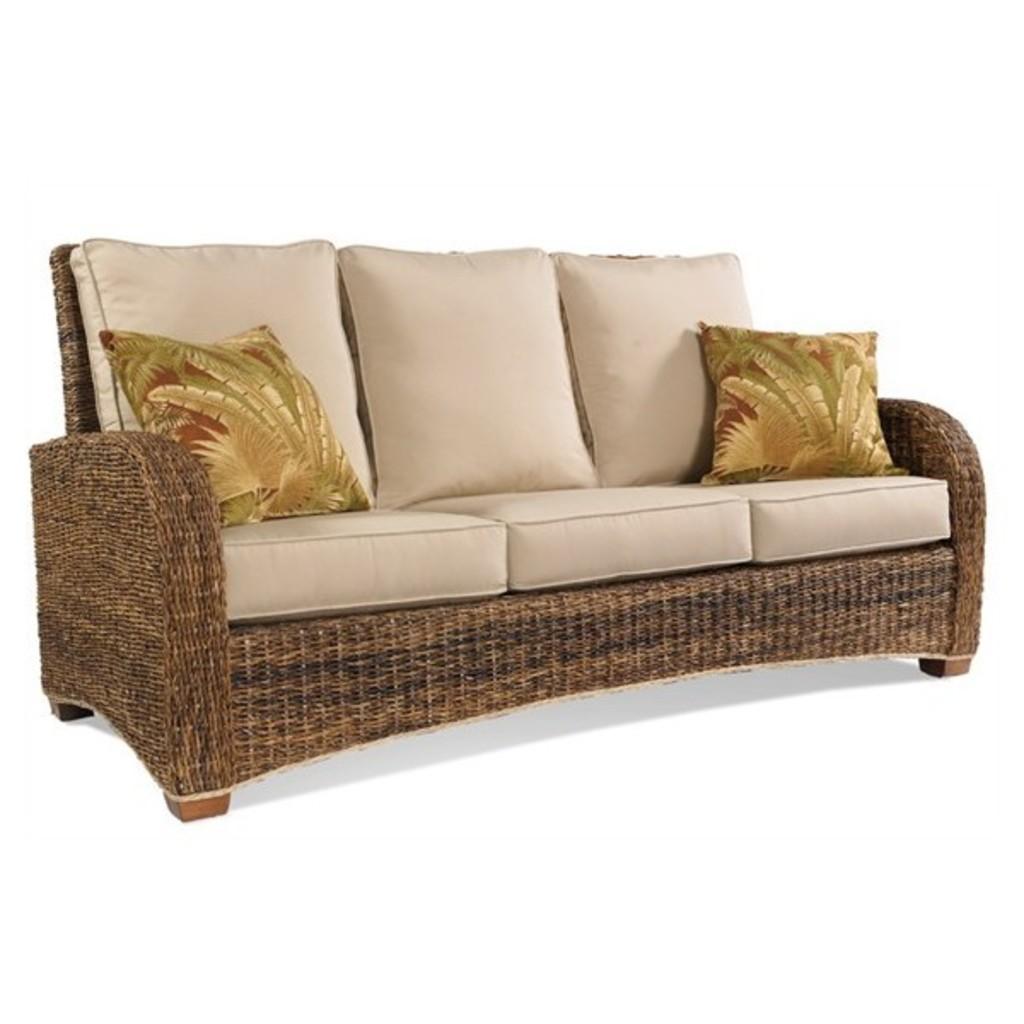Can you describe this image briefly? In this image there is a sofa and on the sofa there are cushions. 